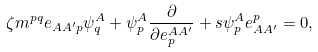<formula> <loc_0><loc_0><loc_500><loc_500>\zeta m ^ { p q } e _ { A A ^ { \prime } p } \psi ^ { A } _ { q } + \psi ^ { A } _ { p } \frac { \partial } { \partial e ^ { A A ^ { \prime } } _ { p } } + s \psi ^ { A } _ { p } e _ { A A ^ { \prime } } ^ { p } = 0 ,</formula> 